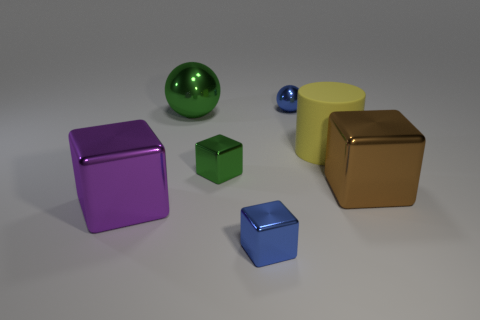Add 3 big shiny objects. How many objects exist? 10 Subtract all red balls. Subtract all yellow cylinders. How many balls are left? 2 Subtract all spheres. How many objects are left? 5 Subtract 0 cyan cylinders. How many objects are left? 7 Subtract all blue metallic blocks. Subtract all large metallic things. How many objects are left? 3 Add 4 blue balls. How many blue balls are left? 5 Add 4 large green objects. How many large green objects exist? 5 